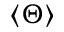Convert formula to latex. <formula><loc_0><loc_0><loc_500><loc_500>\left < \Theta \right ></formula> 